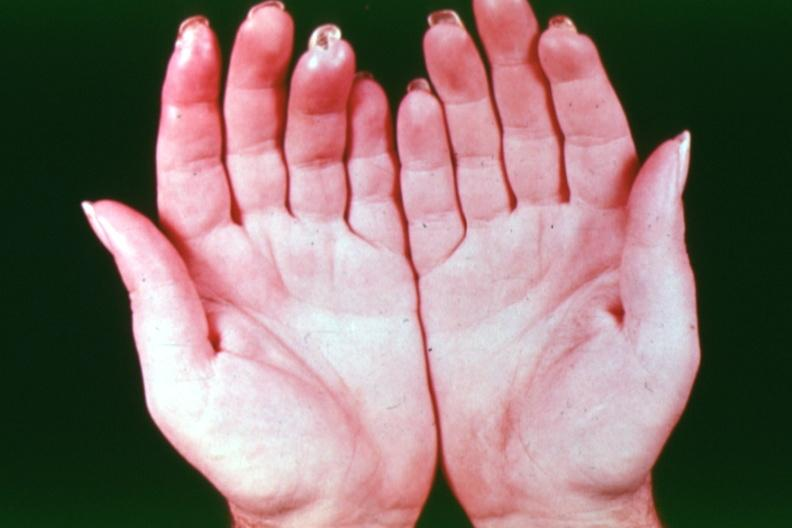what is present?
Answer the question using a single word or phrase. Hand 